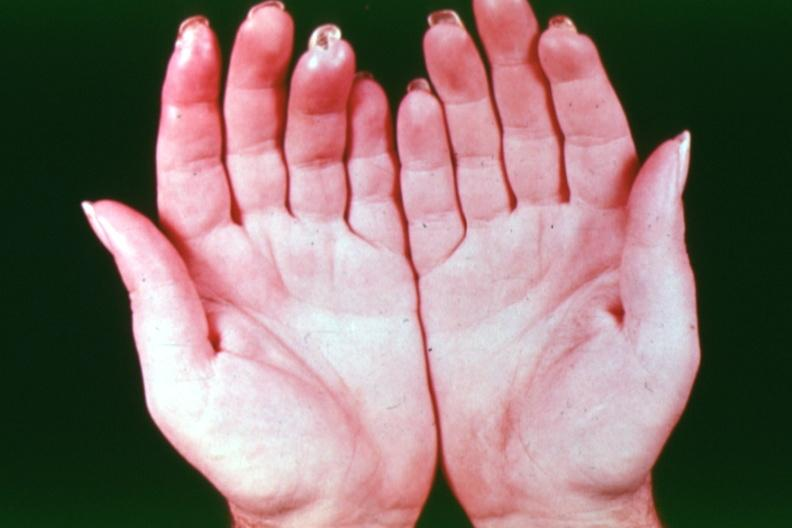what is present?
Answer the question using a single word or phrase. Hand 